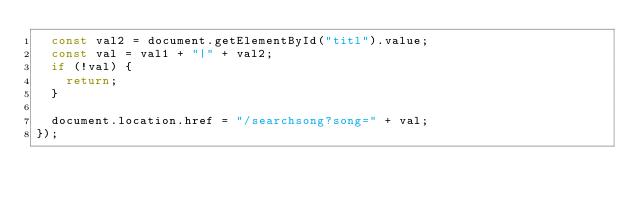<code> <loc_0><loc_0><loc_500><loc_500><_JavaScript_>  const val2 = document.getElementById("titl").value;
  const val = val1 + "|" + val2;
  if (!val) {
    return;
  }

  document.location.href = "/searchsong?song=" + val;
});
</code> 